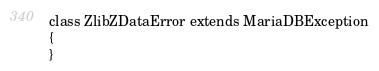Convert code to text. <code><loc_0><loc_0><loc_500><loc_500><_PHP_>class ZlibZDataError extends MariaDBException
{
}
</code> 